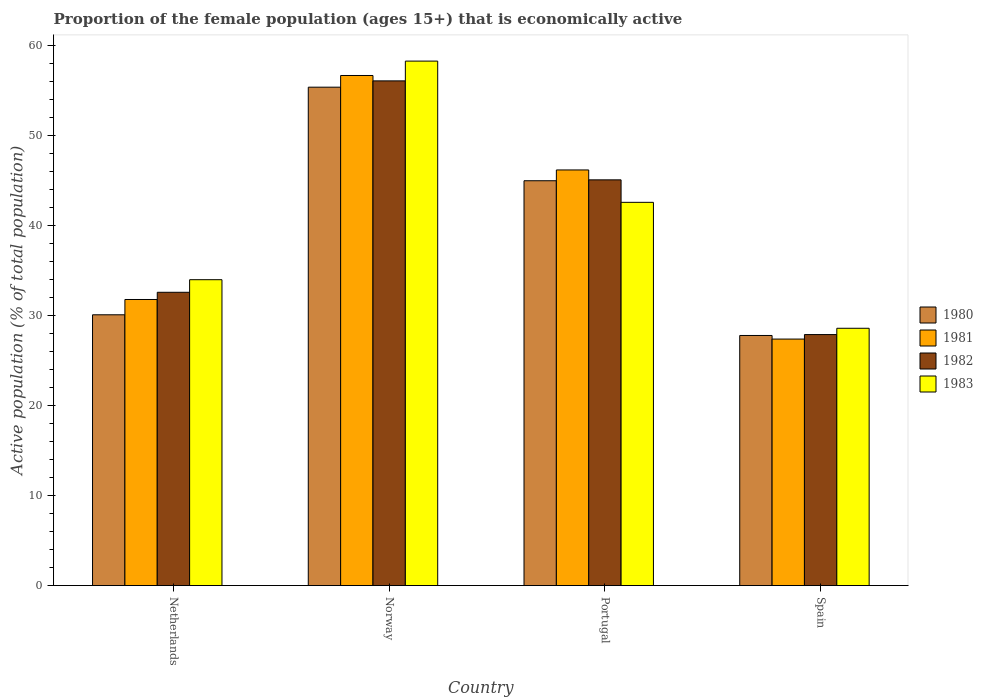How many groups of bars are there?
Provide a short and direct response. 4. Are the number of bars per tick equal to the number of legend labels?
Your response must be concise. Yes. Are the number of bars on each tick of the X-axis equal?
Offer a terse response. Yes. How many bars are there on the 1st tick from the right?
Make the answer very short. 4. In how many cases, is the number of bars for a given country not equal to the number of legend labels?
Keep it short and to the point. 0. What is the proportion of the female population that is economically active in 1982 in Netherlands?
Make the answer very short. 32.6. Across all countries, what is the maximum proportion of the female population that is economically active in 1982?
Your answer should be very brief. 56.1. Across all countries, what is the minimum proportion of the female population that is economically active in 1981?
Offer a terse response. 27.4. What is the total proportion of the female population that is economically active in 1983 in the graph?
Give a very brief answer. 163.5. What is the difference between the proportion of the female population that is economically active in 1982 in Netherlands and that in Norway?
Give a very brief answer. -23.5. What is the difference between the proportion of the female population that is economically active in 1980 in Norway and the proportion of the female population that is economically active in 1982 in Spain?
Keep it short and to the point. 27.5. What is the average proportion of the female population that is economically active in 1980 per country?
Your response must be concise. 39.58. What is the difference between the proportion of the female population that is economically active of/in 1983 and proportion of the female population that is economically active of/in 1980 in Spain?
Give a very brief answer. 0.8. What is the ratio of the proportion of the female population that is economically active in 1980 in Netherlands to that in Portugal?
Ensure brevity in your answer.  0.67. Is the difference between the proportion of the female population that is economically active in 1983 in Netherlands and Spain greater than the difference between the proportion of the female population that is economically active in 1980 in Netherlands and Spain?
Offer a terse response. Yes. What is the difference between the highest and the lowest proportion of the female population that is economically active in 1980?
Provide a succinct answer. 27.6. Is the sum of the proportion of the female population that is economically active in 1981 in Norway and Portugal greater than the maximum proportion of the female population that is economically active in 1983 across all countries?
Ensure brevity in your answer.  Yes. Is it the case that in every country, the sum of the proportion of the female population that is economically active in 1982 and proportion of the female population that is economically active in 1981 is greater than the sum of proportion of the female population that is economically active in 1983 and proportion of the female population that is economically active in 1980?
Make the answer very short. No. What does the 1st bar from the right in Norway represents?
Give a very brief answer. 1983. Is it the case that in every country, the sum of the proportion of the female population that is economically active in 1980 and proportion of the female population that is economically active in 1982 is greater than the proportion of the female population that is economically active in 1983?
Your answer should be compact. Yes. Are all the bars in the graph horizontal?
Your answer should be very brief. No. How many countries are there in the graph?
Offer a terse response. 4. Does the graph contain any zero values?
Ensure brevity in your answer.  No. How many legend labels are there?
Provide a short and direct response. 4. How are the legend labels stacked?
Your response must be concise. Vertical. What is the title of the graph?
Your answer should be compact. Proportion of the female population (ages 15+) that is economically active. What is the label or title of the X-axis?
Give a very brief answer. Country. What is the label or title of the Y-axis?
Make the answer very short. Active population (% of total population). What is the Active population (% of total population) in 1980 in Netherlands?
Ensure brevity in your answer.  30.1. What is the Active population (% of total population) of 1981 in Netherlands?
Give a very brief answer. 31.8. What is the Active population (% of total population) in 1982 in Netherlands?
Offer a very short reply. 32.6. What is the Active population (% of total population) of 1980 in Norway?
Offer a terse response. 55.4. What is the Active population (% of total population) in 1981 in Norway?
Ensure brevity in your answer.  56.7. What is the Active population (% of total population) in 1982 in Norway?
Your answer should be very brief. 56.1. What is the Active population (% of total population) of 1983 in Norway?
Your answer should be very brief. 58.3. What is the Active population (% of total population) in 1980 in Portugal?
Your response must be concise. 45. What is the Active population (% of total population) in 1981 in Portugal?
Your response must be concise. 46.2. What is the Active population (% of total population) of 1982 in Portugal?
Your answer should be very brief. 45.1. What is the Active population (% of total population) in 1983 in Portugal?
Provide a succinct answer. 42.6. What is the Active population (% of total population) in 1980 in Spain?
Provide a succinct answer. 27.8. What is the Active population (% of total population) in 1981 in Spain?
Ensure brevity in your answer.  27.4. What is the Active population (% of total population) in 1982 in Spain?
Ensure brevity in your answer.  27.9. What is the Active population (% of total population) in 1983 in Spain?
Offer a terse response. 28.6. Across all countries, what is the maximum Active population (% of total population) of 1980?
Keep it short and to the point. 55.4. Across all countries, what is the maximum Active population (% of total population) in 1981?
Provide a succinct answer. 56.7. Across all countries, what is the maximum Active population (% of total population) in 1982?
Your response must be concise. 56.1. Across all countries, what is the maximum Active population (% of total population) in 1983?
Provide a short and direct response. 58.3. Across all countries, what is the minimum Active population (% of total population) of 1980?
Ensure brevity in your answer.  27.8. Across all countries, what is the minimum Active population (% of total population) in 1981?
Offer a terse response. 27.4. Across all countries, what is the minimum Active population (% of total population) in 1982?
Provide a succinct answer. 27.9. Across all countries, what is the minimum Active population (% of total population) of 1983?
Make the answer very short. 28.6. What is the total Active population (% of total population) in 1980 in the graph?
Keep it short and to the point. 158.3. What is the total Active population (% of total population) of 1981 in the graph?
Your response must be concise. 162.1. What is the total Active population (% of total population) in 1982 in the graph?
Ensure brevity in your answer.  161.7. What is the total Active population (% of total population) in 1983 in the graph?
Your answer should be very brief. 163.5. What is the difference between the Active population (% of total population) of 1980 in Netherlands and that in Norway?
Your answer should be very brief. -25.3. What is the difference between the Active population (% of total population) of 1981 in Netherlands and that in Norway?
Provide a short and direct response. -24.9. What is the difference between the Active population (% of total population) in 1982 in Netherlands and that in Norway?
Your answer should be very brief. -23.5. What is the difference between the Active population (% of total population) in 1983 in Netherlands and that in Norway?
Your answer should be very brief. -24.3. What is the difference between the Active population (% of total population) of 1980 in Netherlands and that in Portugal?
Keep it short and to the point. -14.9. What is the difference between the Active population (% of total population) of 1981 in Netherlands and that in Portugal?
Your answer should be compact. -14.4. What is the difference between the Active population (% of total population) of 1982 in Netherlands and that in Portugal?
Keep it short and to the point. -12.5. What is the difference between the Active population (% of total population) in 1983 in Netherlands and that in Portugal?
Provide a short and direct response. -8.6. What is the difference between the Active population (% of total population) in 1980 in Netherlands and that in Spain?
Your response must be concise. 2.3. What is the difference between the Active population (% of total population) of 1980 in Norway and that in Portugal?
Your response must be concise. 10.4. What is the difference between the Active population (% of total population) in 1982 in Norway and that in Portugal?
Provide a succinct answer. 11. What is the difference between the Active population (% of total population) of 1980 in Norway and that in Spain?
Provide a succinct answer. 27.6. What is the difference between the Active population (% of total population) in 1981 in Norway and that in Spain?
Make the answer very short. 29.3. What is the difference between the Active population (% of total population) of 1982 in Norway and that in Spain?
Give a very brief answer. 28.2. What is the difference between the Active population (% of total population) in 1983 in Norway and that in Spain?
Provide a succinct answer. 29.7. What is the difference between the Active population (% of total population) of 1981 in Portugal and that in Spain?
Provide a succinct answer. 18.8. What is the difference between the Active population (% of total population) in 1982 in Portugal and that in Spain?
Offer a very short reply. 17.2. What is the difference between the Active population (% of total population) of 1983 in Portugal and that in Spain?
Your response must be concise. 14. What is the difference between the Active population (% of total population) in 1980 in Netherlands and the Active population (% of total population) in 1981 in Norway?
Ensure brevity in your answer.  -26.6. What is the difference between the Active population (% of total population) of 1980 in Netherlands and the Active population (% of total population) of 1982 in Norway?
Your response must be concise. -26. What is the difference between the Active population (% of total population) in 1980 in Netherlands and the Active population (% of total population) in 1983 in Norway?
Your response must be concise. -28.2. What is the difference between the Active population (% of total population) of 1981 in Netherlands and the Active population (% of total population) of 1982 in Norway?
Ensure brevity in your answer.  -24.3. What is the difference between the Active population (% of total population) in 1981 in Netherlands and the Active population (% of total population) in 1983 in Norway?
Provide a succinct answer. -26.5. What is the difference between the Active population (% of total population) in 1982 in Netherlands and the Active population (% of total population) in 1983 in Norway?
Your answer should be compact. -25.7. What is the difference between the Active population (% of total population) of 1980 in Netherlands and the Active population (% of total population) of 1981 in Portugal?
Give a very brief answer. -16.1. What is the difference between the Active population (% of total population) of 1981 in Netherlands and the Active population (% of total population) of 1983 in Portugal?
Provide a short and direct response. -10.8. What is the difference between the Active population (% of total population) in 1982 in Netherlands and the Active population (% of total population) in 1983 in Portugal?
Offer a very short reply. -10. What is the difference between the Active population (% of total population) in 1980 in Netherlands and the Active population (% of total population) in 1983 in Spain?
Ensure brevity in your answer.  1.5. What is the difference between the Active population (% of total population) of 1981 in Netherlands and the Active population (% of total population) of 1982 in Spain?
Your answer should be compact. 3.9. What is the difference between the Active population (% of total population) in 1980 in Norway and the Active population (% of total population) in 1983 in Portugal?
Ensure brevity in your answer.  12.8. What is the difference between the Active population (% of total population) in 1981 in Norway and the Active population (% of total population) in 1982 in Portugal?
Offer a very short reply. 11.6. What is the difference between the Active population (% of total population) of 1982 in Norway and the Active population (% of total population) of 1983 in Portugal?
Your response must be concise. 13.5. What is the difference between the Active population (% of total population) of 1980 in Norway and the Active population (% of total population) of 1981 in Spain?
Provide a short and direct response. 28. What is the difference between the Active population (% of total population) in 1980 in Norway and the Active population (% of total population) in 1982 in Spain?
Your answer should be very brief. 27.5. What is the difference between the Active population (% of total population) of 1980 in Norway and the Active population (% of total population) of 1983 in Spain?
Your answer should be compact. 26.8. What is the difference between the Active population (% of total population) of 1981 in Norway and the Active population (% of total population) of 1982 in Spain?
Provide a short and direct response. 28.8. What is the difference between the Active population (% of total population) of 1981 in Norway and the Active population (% of total population) of 1983 in Spain?
Your response must be concise. 28.1. What is the difference between the Active population (% of total population) in 1982 in Norway and the Active population (% of total population) in 1983 in Spain?
Offer a terse response. 27.5. What is the difference between the Active population (% of total population) of 1980 in Portugal and the Active population (% of total population) of 1983 in Spain?
Your response must be concise. 16.4. What is the difference between the Active population (% of total population) in 1981 in Portugal and the Active population (% of total population) in 1982 in Spain?
Your response must be concise. 18.3. What is the difference between the Active population (% of total population) of 1981 in Portugal and the Active population (% of total population) of 1983 in Spain?
Your answer should be very brief. 17.6. What is the difference between the Active population (% of total population) in 1982 in Portugal and the Active population (% of total population) in 1983 in Spain?
Offer a very short reply. 16.5. What is the average Active population (% of total population) in 1980 per country?
Ensure brevity in your answer.  39.58. What is the average Active population (% of total population) of 1981 per country?
Ensure brevity in your answer.  40.52. What is the average Active population (% of total population) of 1982 per country?
Your response must be concise. 40.42. What is the average Active population (% of total population) of 1983 per country?
Your response must be concise. 40.88. What is the difference between the Active population (% of total population) of 1980 and Active population (% of total population) of 1982 in Netherlands?
Offer a very short reply. -2.5. What is the difference between the Active population (% of total population) of 1980 and Active population (% of total population) of 1983 in Netherlands?
Your answer should be compact. -3.9. What is the difference between the Active population (% of total population) of 1982 and Active population (% of total population) of 1983 in Netherlands?
Keep it short and to the point. -1.4. What is the difference between the Active population (% of total population) of 1980 and Active population (% of total population) of 1981 in Norway?
Offer a terse response. -1.3. What is the difference between the Active population (% of total population) of 1981 and Active population (% of total population) of 1982 in Norway?
Ensure brevity in your answer.  0.6. What is the difference between the Active population (% of total population) in 1982 and Active population (% of total population) in 1983 in Norway?
Keep it short and to the point. -2.2. What is the difference between the Active population (% of total population) of 1980 and Active population (% of total population) of 1981 in Portugal?
Your answer should be compact. -1.2. What is the difference between the Active population (% of total population) in 1980 and Active population (% of total population) in 1982 in Portugal?
Ensure brevity in your answer.  -0.1. What is the difference between the Active population (% of total population) of 1982 and Active population (% of total population) of 1983 in Portugal?
Offer a terse response. 2.5. What is the difference between the Active population (% of total population) in 1980 and Active population (% of total population) in 1981 in Spain?
Make the answer very short. 0.4. What is the difference between the Active population (% of total population) of 1981 and Active population (% of total population) of 1982 in Spain?
Your response must be concise. -0.5. What is the difference between the Active population (% of total population) in 1981 and Active population (% of total population) in 1983 in Spain?
Make the answer very short. -1.2. What is the difference between the Active population (% of total population) of 1982 and Active population (% of total population) of 1983 in Spain?
Provide a short and direct response. -0.7. What is the ratio of the Active population (% of total population) of 1980 in Netherlands to that in Norway?
Offer a very short reply. 0.54. What is the ratio of the Active population (% of total population) in 1981 in Netherlands to that in Norway?
Offer a terse response. 0.56. What is the ratio of the Active population (% of total population) in 1982 in Netherlands to that in Norway?
Make the answer very short. 0.58. What is the ratio of the Active population (% of total population) in 1983 in Netherlands to that in Norway?
Provide a short and direct response. 0.58. What is the ratio of the Active population (% of total population) in 1980 in Netherlands to that in Portugal?
Your response must be concise. 0.67. What is the ratio of the Active population (% of total population) of 1981 in Netherlands to that in Portugal?
Offer a terse response. 0.69. What is the ratio of the Active population (% of total population) in 1982 in Netherlands to that in Portugal?
Your answer should be compact. 0.72. What is the ratio of the Active population (% of total population) of 1983 in Netherlands to that in Portugal?
Your answer should be very brief. 0.8. What is the ratio of the Active population (% of total population) in 1980 in Netherlands to that in Spain?
Your response must be concise. 1.08. What is the ratio of the Active population (% of total population) of 1981 in Netherlands to that in Spain?
Your answer should be compact. 1.16. What is the ratio of the Active population (% of total population) in 1982 in Netherlands to that in Spain?
Make the answer very short. 1.17. What is the ratio of the Active population (% of total population) in 1983 in Netherlands to that in Spain?
Give a very brief answer. 1.19. What is the ratio of the Active population (% of total population) in 1980 in Norway to that in Portugal?
Offer a terse response. 1.23. What is the ratio of the Active population (% of total population) of 1981 in Norway to that in Portugal?
Provide a short and direct response. 1.23. What is the ratio of the Active population (% of total population) in 1982 in Norway to that in Portugal?
Offer a very short reply. 1.24. What is the ratio of the Active population (% of total population) in 1983 in Norway to that in Portugal?
Give a very brief answer. 1.37. What is the ratio of the Active population (% of total population) in 1980 in Norway to that in Spain?
Make the answer very short. 1.99. What is the ratio of the Active population (% of total population) in 1981 in Norway to that in Spain?
Offer a very short reply. 2.07. What is the ratio of the Active population (% of total population) in 1982 in Norway to that in Spain?
Offer a very short reply. 2.01. What is the ratio of the Active population (% of total population) of 1983 in Norway to that in Spain?
Provide a short and direct response. 2.04. What is the ratio of the Active population (% of total population) of 1980 in Portugal to that in Spain?
Your answer should be compact. 1.62. What is the ratio of the Active population (% of total population) of 1981 in Portugal to that in Spain?
Your answer should be very brief. 1.69. What is the ratio of the Active population (% of total population) of 1982 in Portugal to that in Spain?
Your response must be concise. 1.62. What is the ratio of the Active population (% of total population) of 1983 in Portugal to that in Spain?
Provide a succinct answer. 1.49. What is the difference between the highest and the second highest Active population (% of total population) of 1980?
Offer a very short reply. 10.4. What is the difference between the highest and the second highest Active population (% of total population) of 1981?
Offer a very short reply. 10.5. What is the difference between the highest and the second highest Active population (% of total population) of 1982?
Your answer should be very brief. 11. What is the difference between the highest and the lowest Active population (% of total population) of 1980?
Provide a short and direct response. 27.6. What is the difference between the highest and the lowest Active population (% of total population) of 1981?
Offer a terse response. 29.3. What is the difference between the highest and the lowest Active population (% of total population) of 1982?
Make the answer very short. 28.2. What is the difference between the highest and the lowest Active population (% of total population) in 1983?
Offer a terse response. 29.7. 